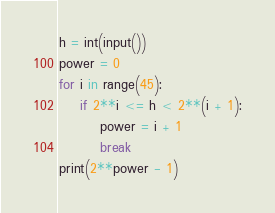<code> <loc_0><loc_0><loc_500><loc_500><_Python_>h = int(input())
power = 0
for i in range(45):
    if 2**i <= h < 2**(i + 1):
        power = i + 1
        break
print(2**power - 1) </code> 